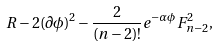Convert formula to latex. <formula><loc_0><loc_0><loc_500><loc_500>R - 2 ( \partial \phi ) ^ { 2 } - { \frac { 2 } { ( n - 2 ) ! } } e ^ { - \alpha \phi } F _ { n - 2 } ^ { 2 } ,</formula> 